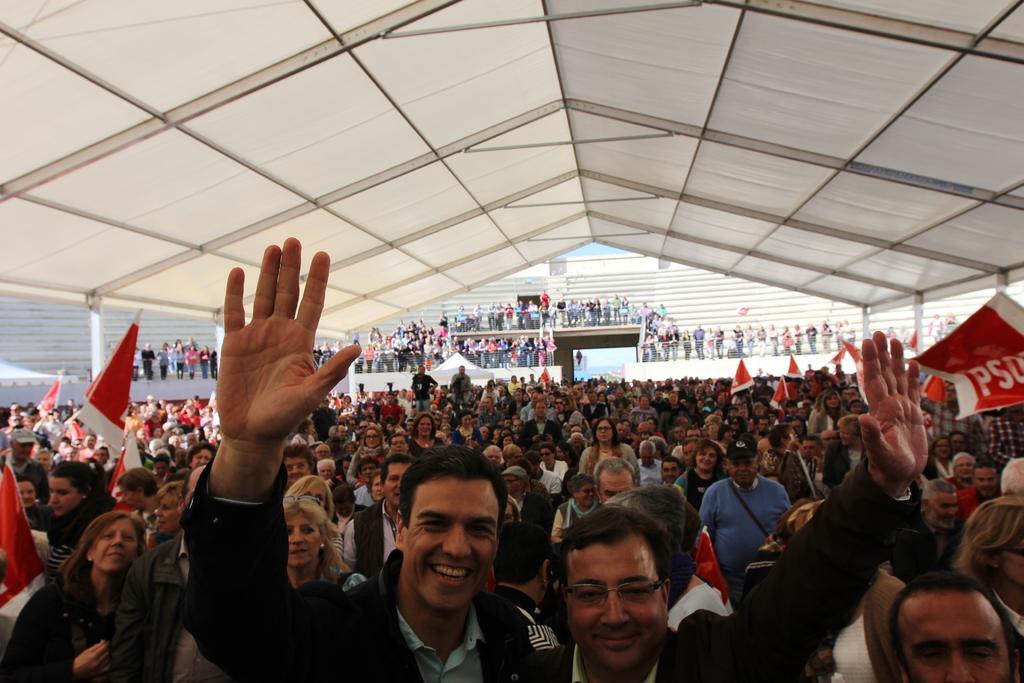How would you summarize this image in a sentence or two? In this image we can see a few people, some of them are holding flags, and placards, there are text on the placards, also we can see the sky. 